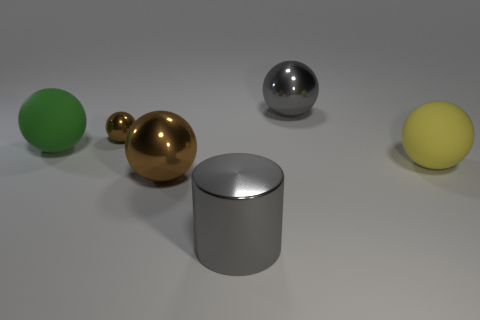Add 4 metal cylinders. How many objects exist? 10 Subtract 0 green cylinders. How many objects are left? 6 Subtract all balls. How many objects are left? 1 Subtract 1 cylinders. How many cylinders are left? 0 Subtract all yellow balls. Subtract all green cubes. How many balls are left? 4 Subtract all cyan balls. How many cyan cylinders are left? 0 Subtract all blue metal cubes. Subtract all big brown metallic things. How many objects are left? 5 Add 2 matte objects. How many matte objects are left? 4 Add 5 big yellow rubber balls. How many big yellow rubber balls exist? 6 Subtract all gray balls. How many balls are left? 4 